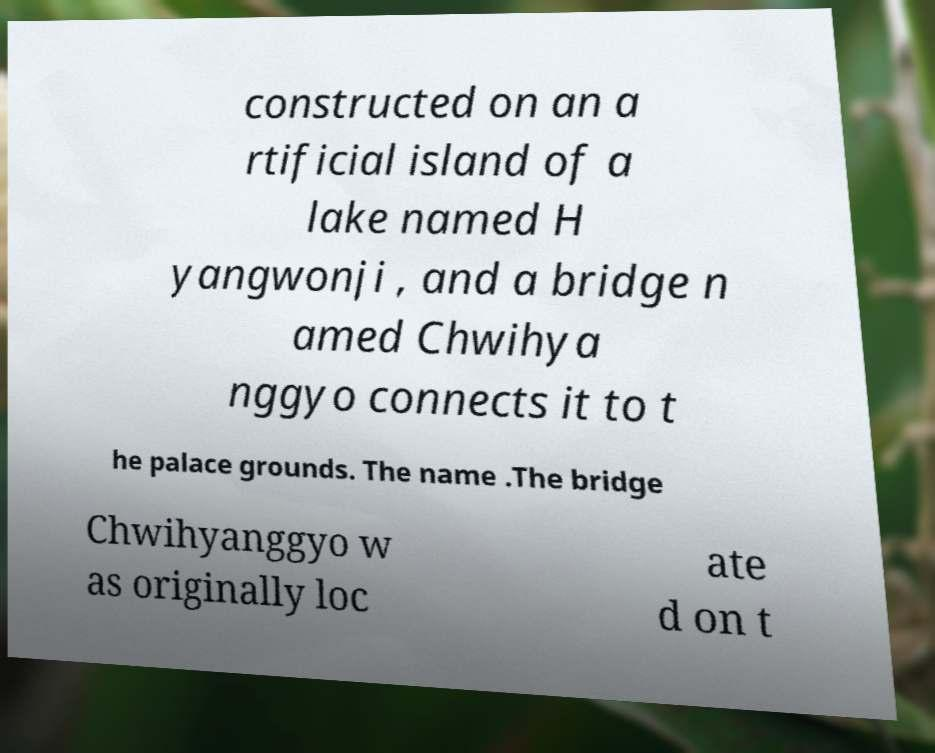For documentation purposes, I need the text within this image transcribed. Could you provide that? constructed on an a rtificial island of a lake named H yangwonji , and a bridge n amed Chwihya nggyo connects it to t he palace grounds. The name .The bridge Chwihyanggyo w as originally loc ate d on t 